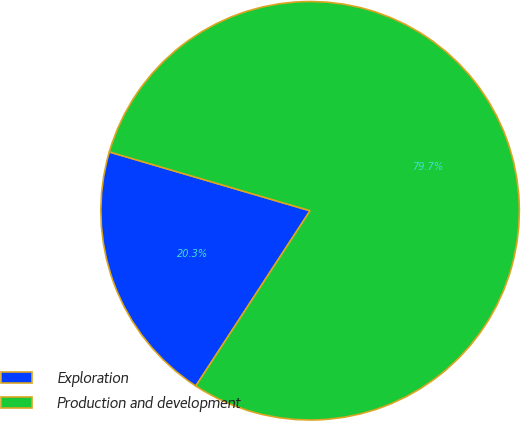Convert chart to OTSL. <chart><loc_0><loc_0><loc_500><loc_500><pie_chart><fcel>Exploration<fcel>Production and development<nl><fcel>20.34%<fcel>79.66%<nl></chart> 